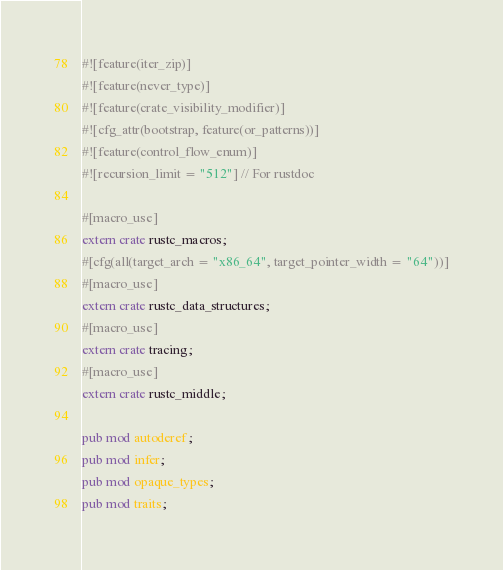Convert code to text. <code><loc_0><loc_0><loc_500><loc_500><_Rust_>#![feature(iter_zip)]
#![feature(never_type)]
#![feature(crate_visibility_modifier)]
#![cfg_attr(bootstrap, feature(or_patterns))]
#![feature(control_flow_enum)]
#![recursion_limit = "512"] // For rustdoc

#[macro_use]
extern crate rustc_macros;
#[cfg(all(target_arch = "x86_64", target_pointer_width = "64"))]
#[macro_use]
extern crate rustc_data_structures;
#[macro_use]
extern crate tracing;
#[macro_use]
extern crate rustc_middle;

pub mod autoderef;
pub mod infer;
pub mod opaque_types;
pub mod traits;
</code> 